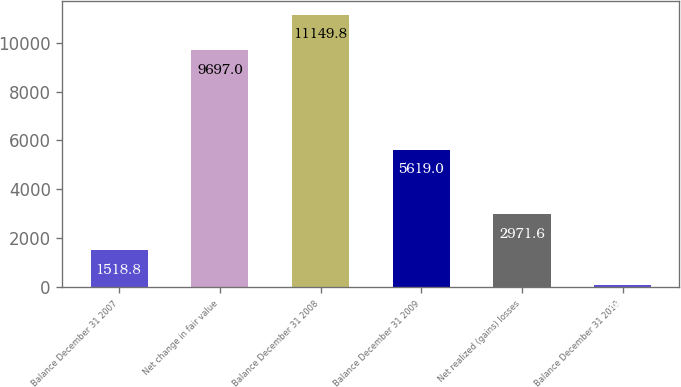Convert chart. <chart><loc_0><loc_0><loc_500><loc_500><bar_chart><fcel>Balance December 31 2007<fcel>Net change in fair value<fcel>Balance December 31 2008<fcel>Balance December 31 2009<fcel>Net realized (gains) losses<fcel>Balance December 31 2010<nl><fcel>1518.8<fcel>9697<fcel>11149.8<fcel>5619<fcel>2971.6<fcel>66<nl></chart> 